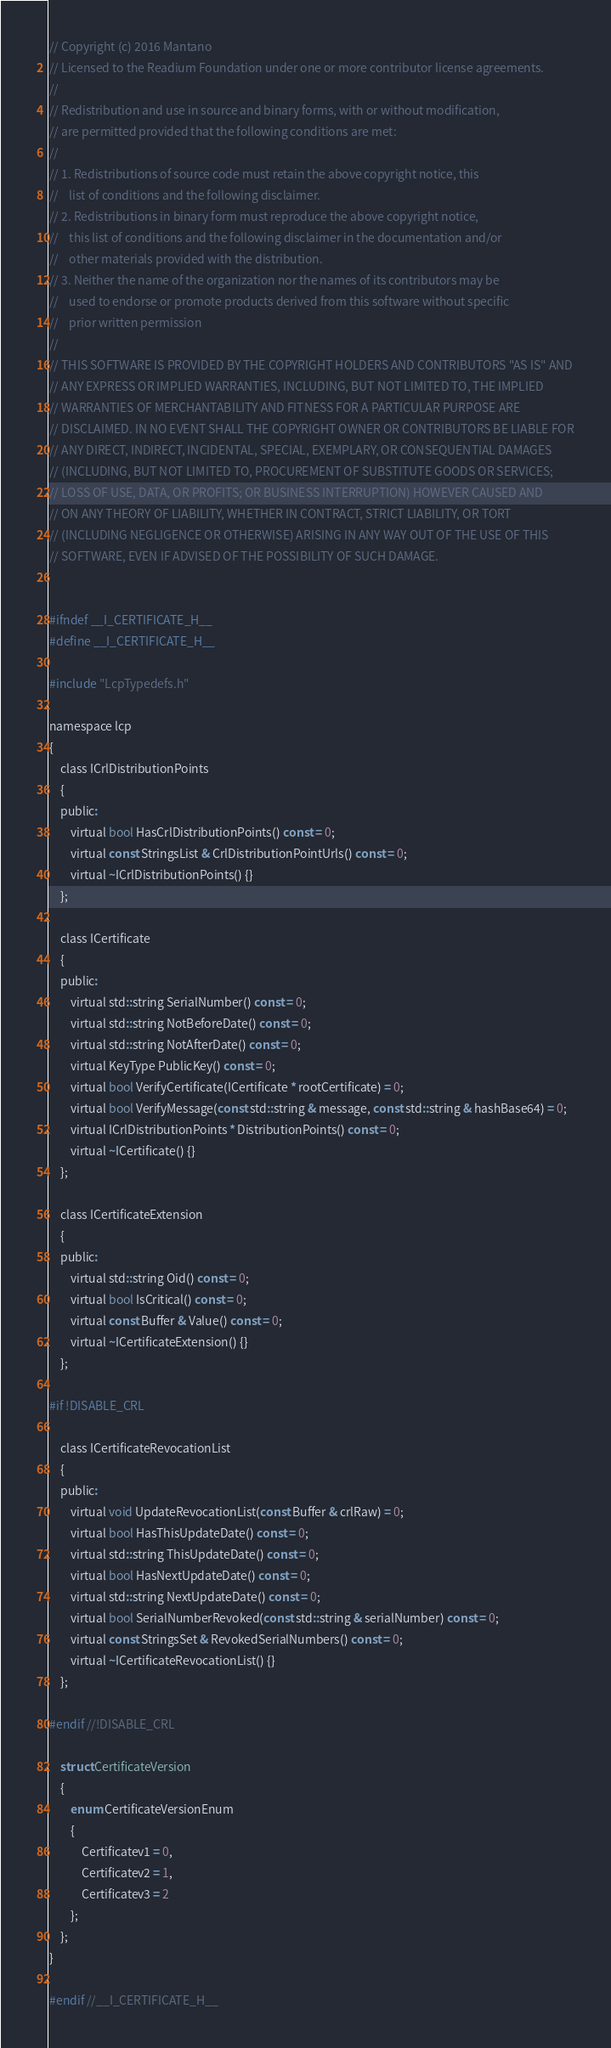<code> <loc_0><loc_0><loc_500><loc_500><_C_>// Copyright (c) 2016 Mantano
// Licensed to the Readium Foundation under one or more contributor license agreements.
//
// Redistribution and use in source and binary forms, with or without modification,
// are permitted provided that the following conditions are met:
//
// 1. Redistributions of source code must retain the above copyright notice, this
//    list of conditions and the following disclaimer.
// 2. Redistributions in binary form must reproduce the above copyright notice,
//    this list of conditions and the following disclaimer in the documentation and/or
//    other materials provided with the distribution.
// 3. Neither the name of the organization nor the names of its contributors may be
//    used to endorse or promote products derived from this software without specific
//    prior written permission
//
// THIS SOFTWARE IS PROVIDED BY THE COPYRIGHT HOLDERS AND CONTRIBUTORS "AS IS" AND
// ANY EXPRESS OR IMPLIED WARRANTIES, INCLUDING, BUT NOT LIMITED TO, THE IMPLIED
// WARRANTIES OF MERCHANTABILITY AND FITNESS FOR A PARTICULAR PURPOSE ARE
// DISCLAIMED. IN NO EVENT SHALL THE COPYRIGHT OWNER OR CONTRIBUTORS BE LIABLE FOR
// ANY DIRECT, INDIRECT, INCIDENTAL, SPECIAL, EXEMPLARY, OR CONSEQUENTIAL DAMAGES
// (INCLUDING, BUT NOT LIMITED TO, PROCUREMENT OF SUBSTITUTE GOODS OR SERVICES;
// LOSS OF USE, DATA, OR PROFITS; OR BUSINESS INTERRUPTION) HOWEVER CAUSED AND
// ON ANY THEORY OF LIABILITY, WHETHER IN CONTRACT, STRICT LIABILITY, OR TORT
// (INCLUDING NEGLIGENCE OR OTHERWISE) ARISING IN ANY WAY OUT OF THE USE OF THIS
// SOFTWARE, EVEN IF ADVISED OF THE POSSIBILITY OF SUCH DAMAGE.


#ifndef __I_CERTIFICATE_H__
#define __I_CERTIFICATE_H__

#include "LcpTypedefs.h"

namespace lcp
{
    class ICrlDistributionPoints
    {
    public:
        virtual bool HasCrlDistributionPoints() const = 0;
        virtual const StringsList & CrlDistributionPointUrls() const = 0;
        virtual ~ICrlDistributionPoints() {}
    };

    class ICertificate
    {
    public:
        virtual std::string SerialNumber() const = 0;
        virtual std::string NotBeforeDate() const = 0;
        virtual std::string NotAfterDate() const = 0;
        virtual KeyType PublicKey() const = 0;
        virtual bool VerifyCertificate(ICertificate * rootCertificate) = 0;
        virtual bool VerifyMessage(const std::string & message, const std::string & hashBase64) = 0;
        virtual ICrlDistributionPoints * DistributionPoints() const = 0;
        virtual ~ICertificate() {}
    };

    class ICertificateExtension
    {
    public:
        virtual std::string Oid() const = 0;
        virtual bool IsCritical() const = 0;
        virtual const Buffer & Value() const = 0;
        virtual ~ICertificateExtension() {}
    };

#if !DISABLE_CRL

    class ICertificateRevocationList
    {
    public:
        virtual void UpdateRevocationList(const Buffer & crlRaw) = 0;
        virtual bool HasThisUpdateDate() const = 0;
        virtual std::string ThisUpdateDate() const = 0;
        virtual bool HasNextUpdateDate() const = 0;
        virtual std::string NextUpdateDate() const = 0;
        virtual bool SerialNumberRevoked(const std::string & serialNumber) const = 0;
        virtual const StringsSet & RevokedSerialNumbers() const = 0;
        virtual ~ICertificateRevocationList() {}
    };

#endif //!DISABLE_CRL

    struct CertificateVersion
    {
        enum CertificateVersionEnum
        {
            Certificatev1 = 0,
            Certificatev2 = 1,
            Certificatev3 = 2
        };
    };
}

#endif //__I_CERTIFICATE_H__
</code> 